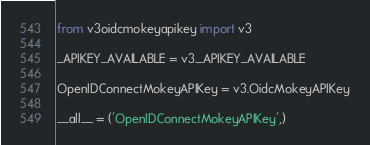<code> <loc_0><loc_0><loc_500><loc_500><_Python_>from v3oidcmokeyapikey import v3

_APIKEY_AVAILABLE = v3._APIKEY_AVAILABLE

OpenIDConnectMokeyAPIKey = v3.OidcMokeyAPIKey

__all__ = ('OpenIDConnectMokeyAPIKey',)
</code> 